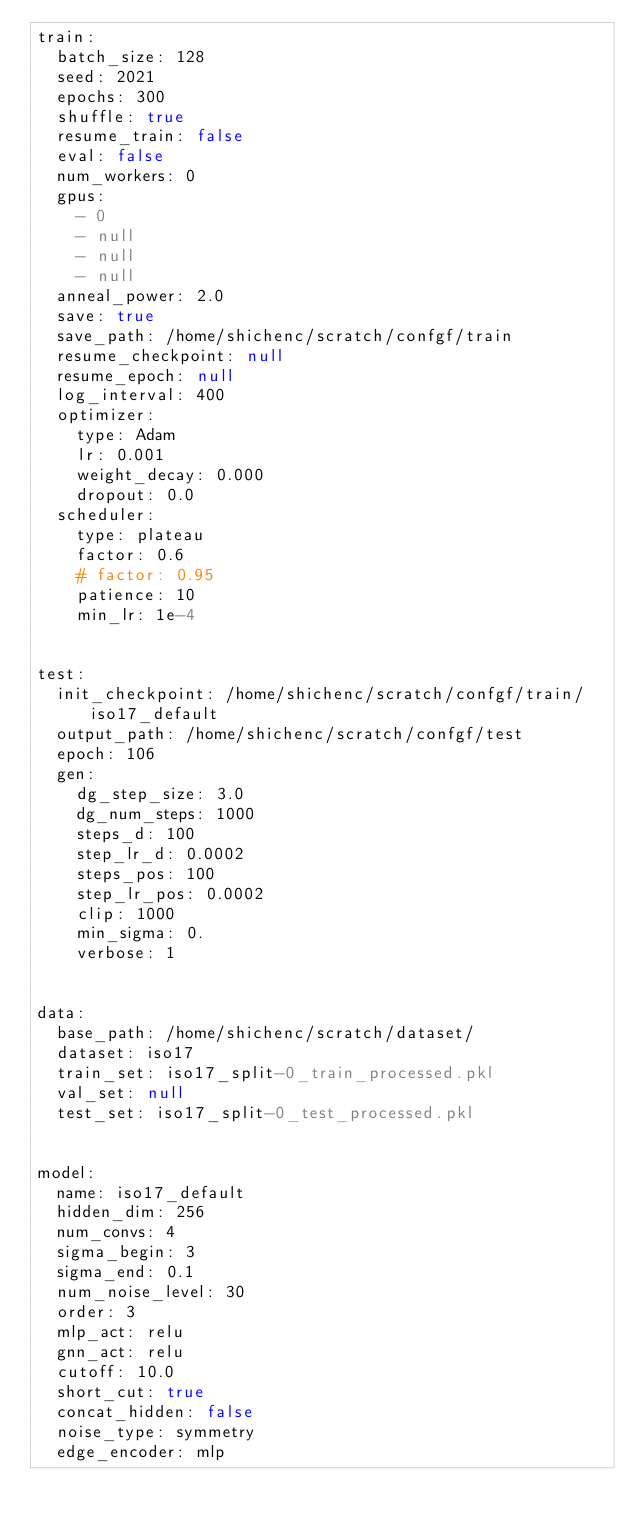Convert code to text. <code><loc_0><loc_0><loc_500><loc_500><_YAML_>train:
  batch_size: 128
  seed: 2021
  epochs: 300
  shuffle: true
  resume_train: false
  eval: false
  num_workers: 0
  gpus:
    - 0
    - null
    - null
    - null
  anneal_power: 2.0
  save: true
  save_path: /home/shichenc/scratch/confgf/train
  resume_checkpoint: null
  resume_epoch: null 
  log_interval: 400
  optimizer:
    type: Adam
    lr: 0.001
    weight_decay: 0.000
    dropout: 0.0
  scheduler:
    type: plateau
    factor: 0.6
    # factor: 0.95
    patience: 10
    min_lr: 1e-4  


test:
  init_checkpoint: /home/shichenc/scratch/confgf/train/iso17_default
  output_path: /home/shichenc/scratch/confgf/test
  epoch: 106
  gen:
    dg_step_size: 3.0
    dg_num_steps: 1000  
    steps_d: 100
    step_lr_d: 0.0002
    steps_pos: 100
    step_lr_pos: 0.0002
    clip: 1000
    min_sigma: 0.
    verbose: 1  


data:
  base_path: /home/shichenc/scratch/dataset/
  dataset: iso17
  train_set: iso17_split-0_train_processed.pkl
  val_set: null
  test_set: iso17_split-0_test_processed.pkl

  
model:
  name: iso17_default
  hidden_dim: 256
  num_convs: 4
  sigma_begin: 3
  sigma_end: 0.1
  num_noise_level: 30
  order: 3
  mlp_act: relu
  gnn_act: relu
  cutoff: 10.0
  short_cut: true
  concat_hidden: false   
  noise_type: symmetry
  edge_encoder: mlp

</code> 